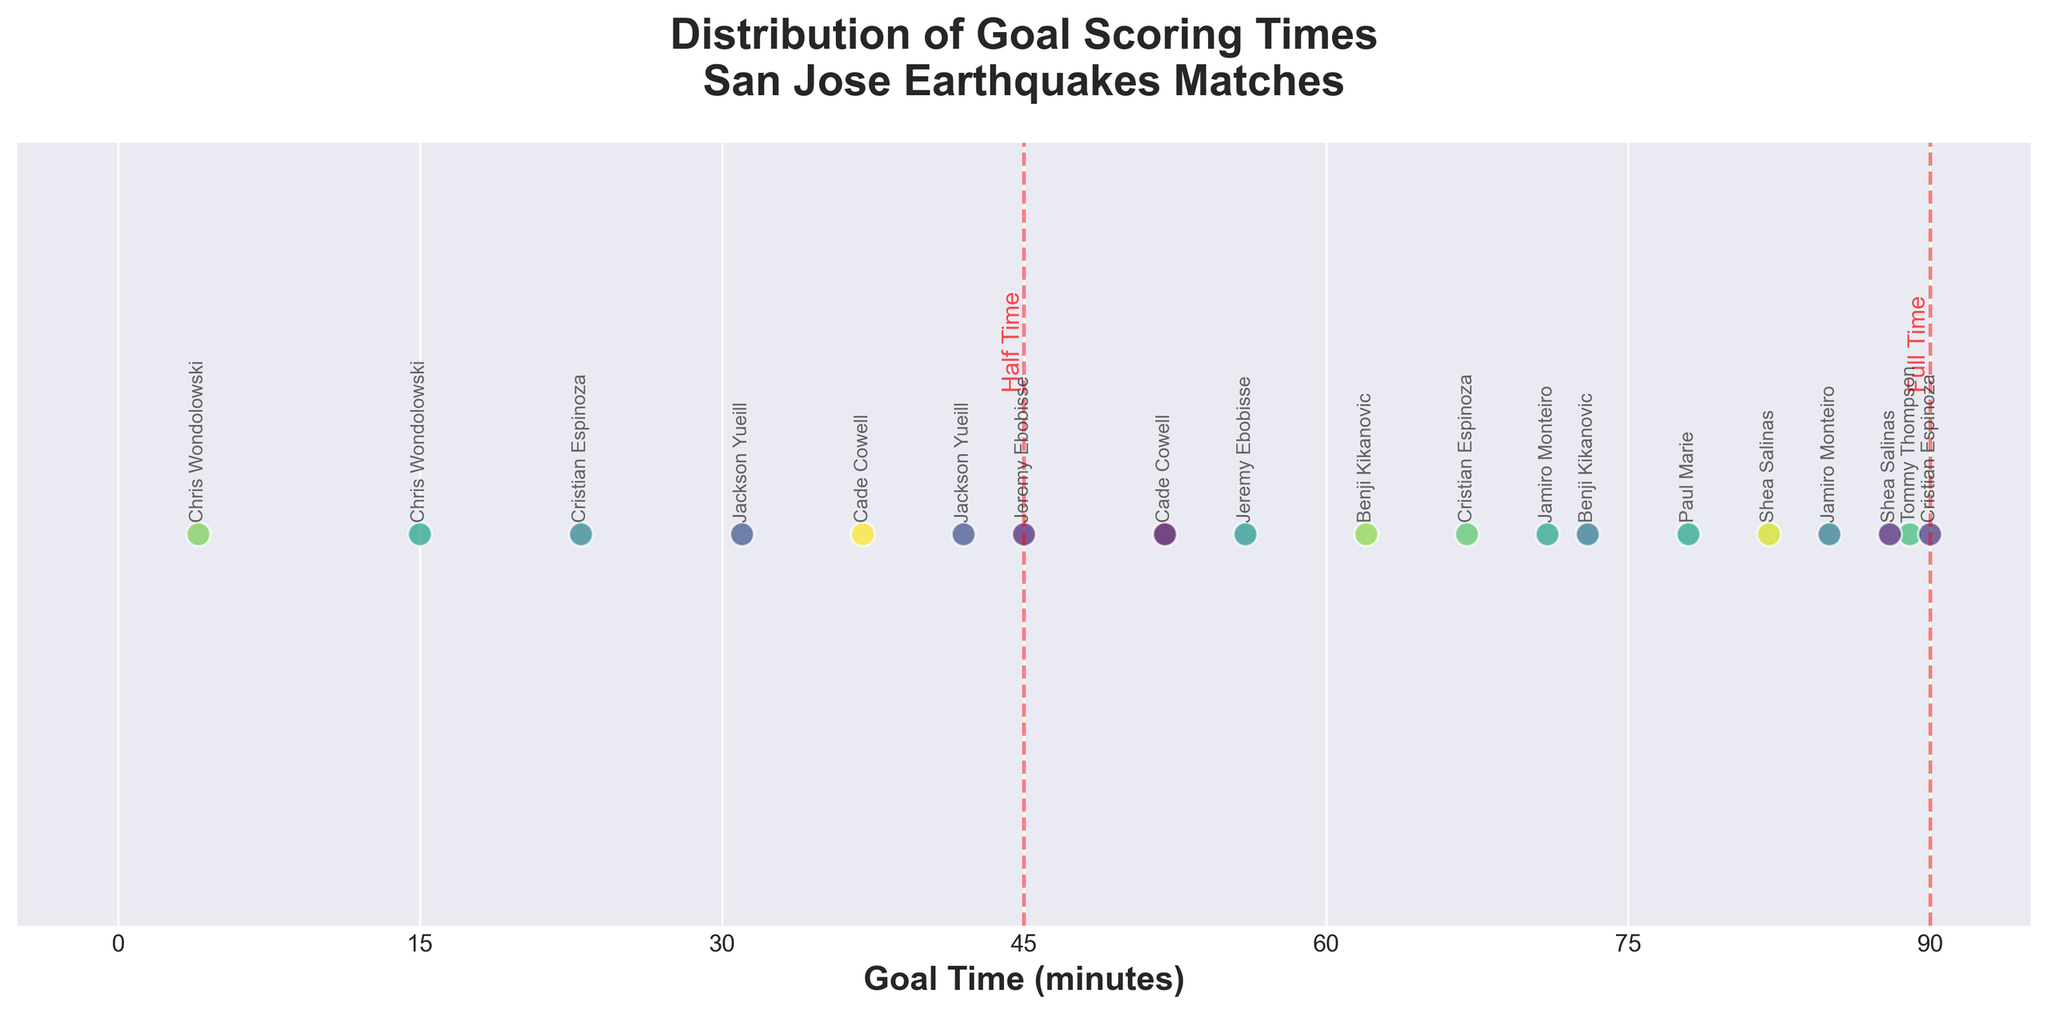What is the title of the plot? The title of the plot is displayed at the top in a larger font and reads, "Distribution of Goal Scoring Times\nSan Jose Earthquakes Matches"
Answer: Distribution of Goal Scoring Times\nSan Jose Earthquakes Matches How many goals were scored after the 75th minute? The plot shows individual goal times along the x-axis, and we count the points beyond the 75th minute mark. There are 3 such points: 78, 82, 89.
Answer: 3 What does the red dashed line at the 45th minute represent? The red dashed line at the 45th minute is annotated with the text "Half Time," indicating the end of the first half of the match.
Answer: Half Time Which player scored the earliest goal depicted in the plot? The plot includes data points labeled with player names. The earliest goal, occurring at the 4th minute, is labeled "Chris Wondolowski."
Answer: Chris Wondolowski What is the range of minutes within which Jamiro Monteiro scored goals? By locating the labels for "Jamiro Monteiro" on the plot, we see that he scored at the 71st and 85th minutes. So, the range is from the 71st to the 85th minute.
Answer: 71 to 85 Compare the number of goals scored in the first half versus the second half. The plot is divided by a red dashed line at the 45th minute. Counting the points: In the first half (before 45'), there are 5 goals. In the second half (including and after 45'), there are 13 goals.
Answer: 5 goals in the first half, 13 goals in the second half How many individual players are recorded in the dataset? By counting the unique player names annotated on the plot, we find that there are 8 individual players.
Answer: 8 What is the median goal time in the dataset? Sorting the goal times in ascending order: [4, 15, 23, 31, 37, 42, 45, 52, 56, 62, 67, 71, 73, 78, 82, 85, 88, 89, 90]. The median is the middle value, which is the 10th value in this list, or 56 minutes.
Answer: 56 minutes 